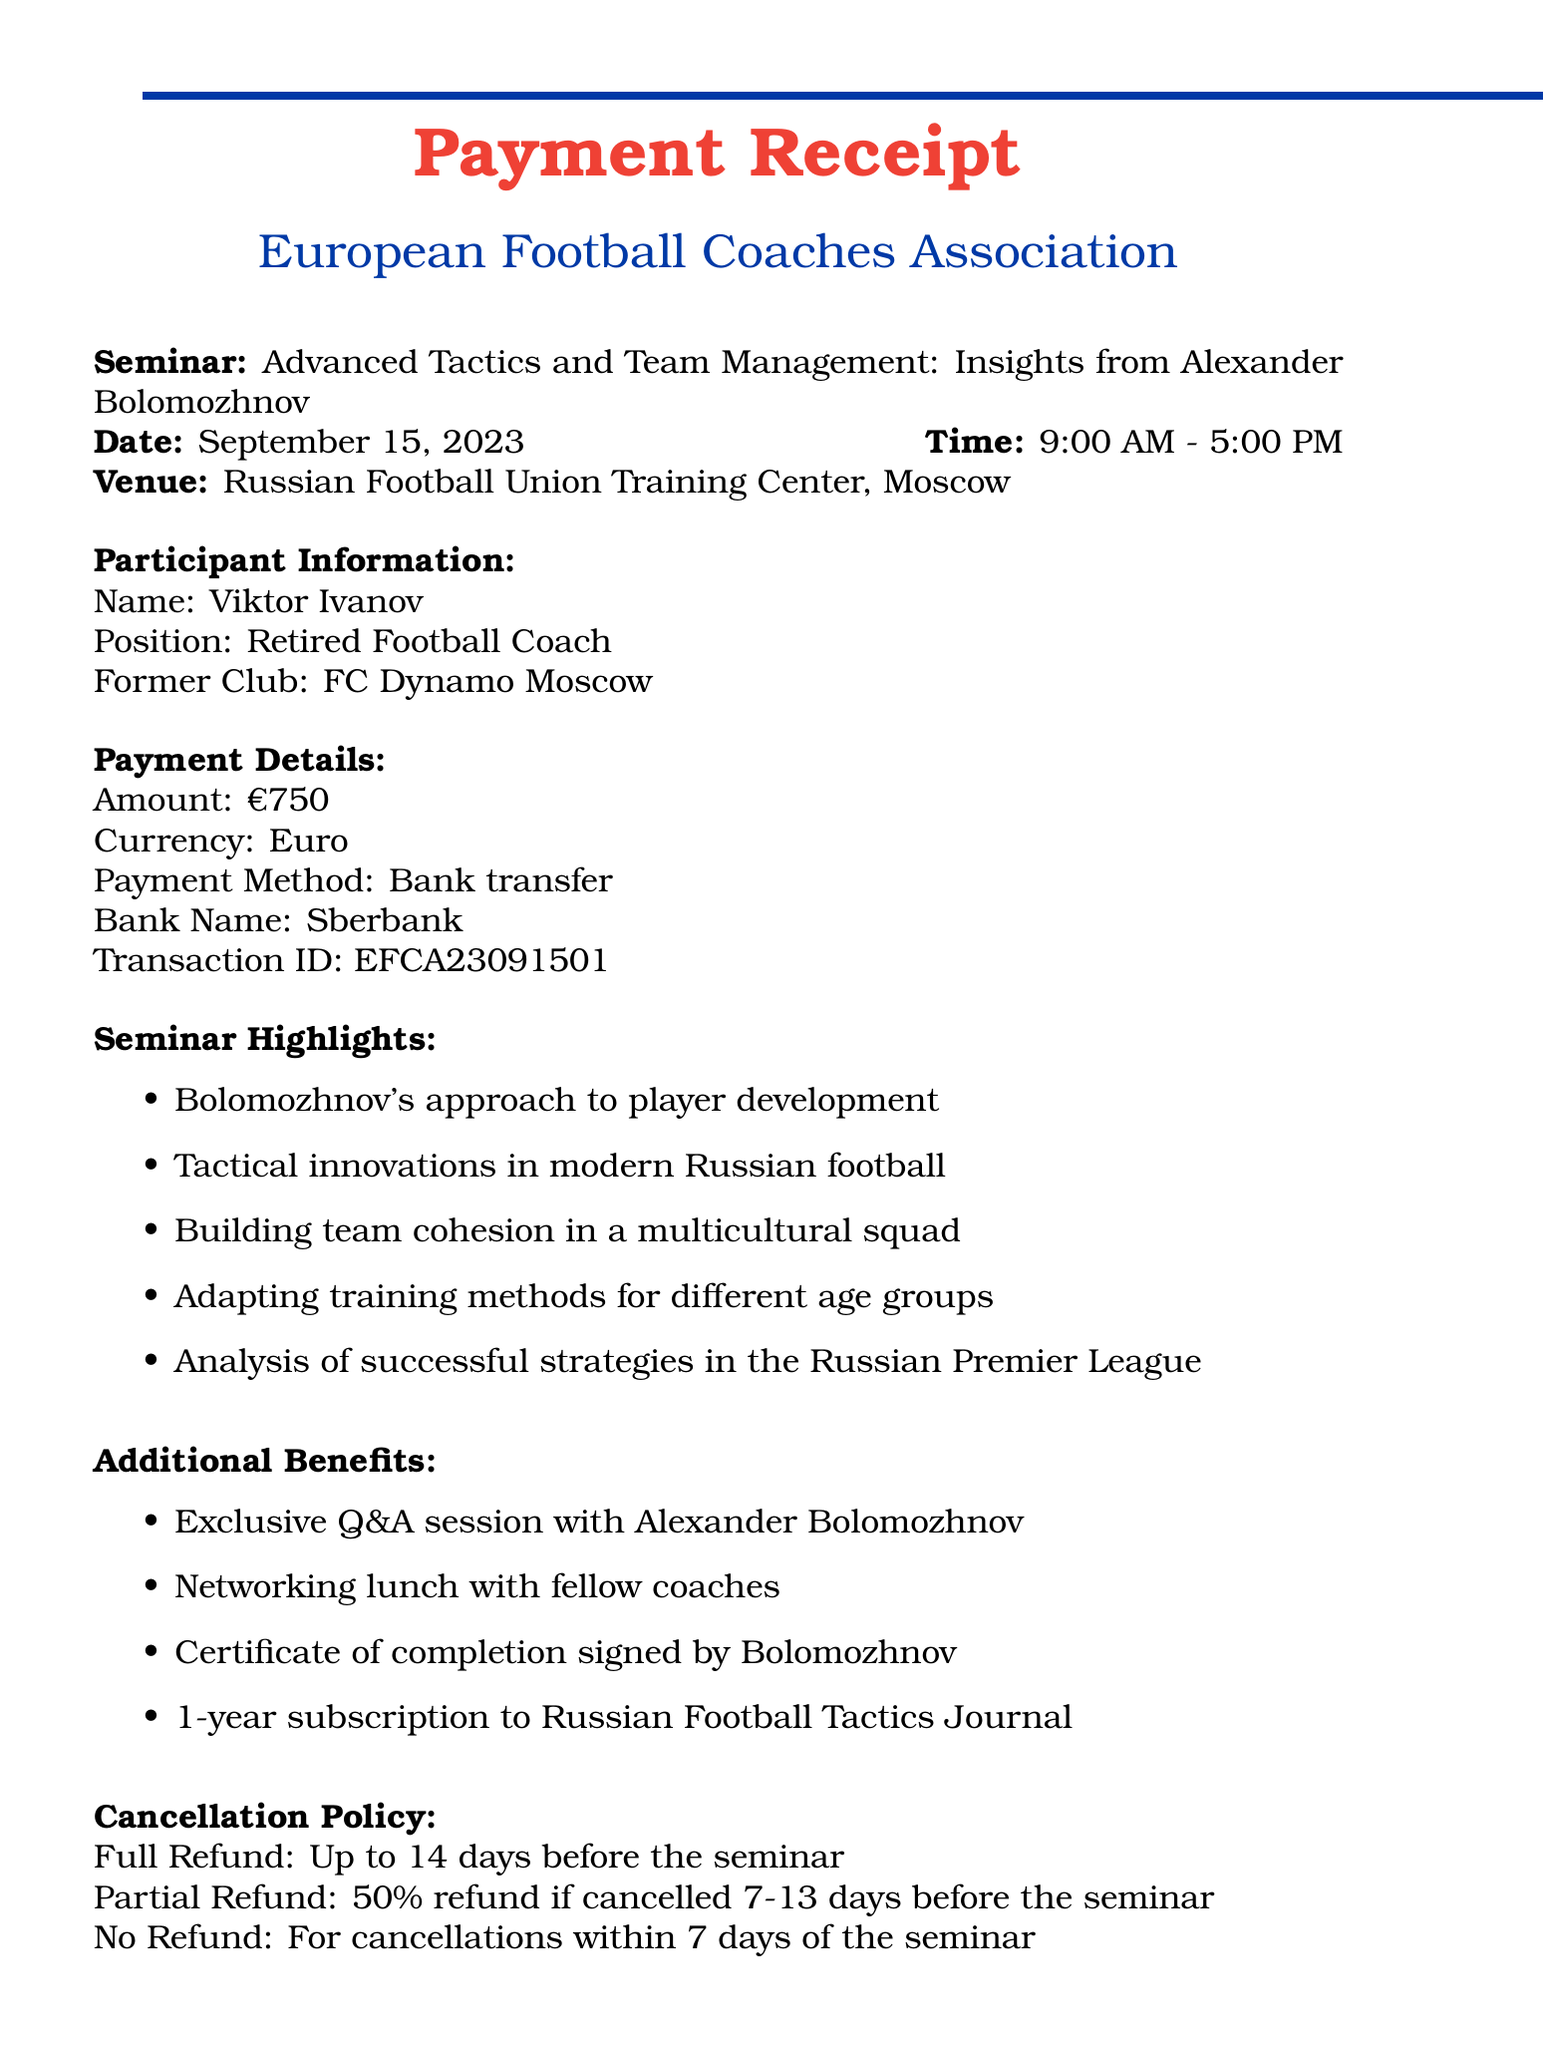What is the title of the seminar? The title of the seminar is specified in the document under seminar details.
Answer: Advanced Tactics and Team Management: Insights from Alexander Bolomozhnov Who is the organizer of the seminar? The organizer's name is mentioned in the seminar details section of the document.
Answer: European Football Coaches Association What is the date of the seminar? The date can be found in the seminar details section of the document.
Answer: September 15, 2023 How much was the payment for the seminar? The amount of payment is explicitly stated in the payment details section of the document.
Answer: €750 What is the transaction ID for the payment? The transaction ID is listed under payment details in the document.
Answer: EFCA23091501 What type of refund is offered if cancellation is made 10 days before the seminar? The cancellation policy specifies the type of refund available depending on the cancellation timeframe.
Answer: 50% refund What benefit includes interaction with the speaker? The additional benefits section mentions a specific interaction opportunity with the speaker.
Answer: Exclusive Q&A session with Alexander Bolomozhnov Where is the seminar venue located? The venue location is provided in the seminar details section.
Answer: Russian Football Union Training Center, Moscow What role does Alexander Bolomozhnov currently hold? His current role is stated in the speaker bio section of the document.
Answer: Technical Director, Russian Football Union 